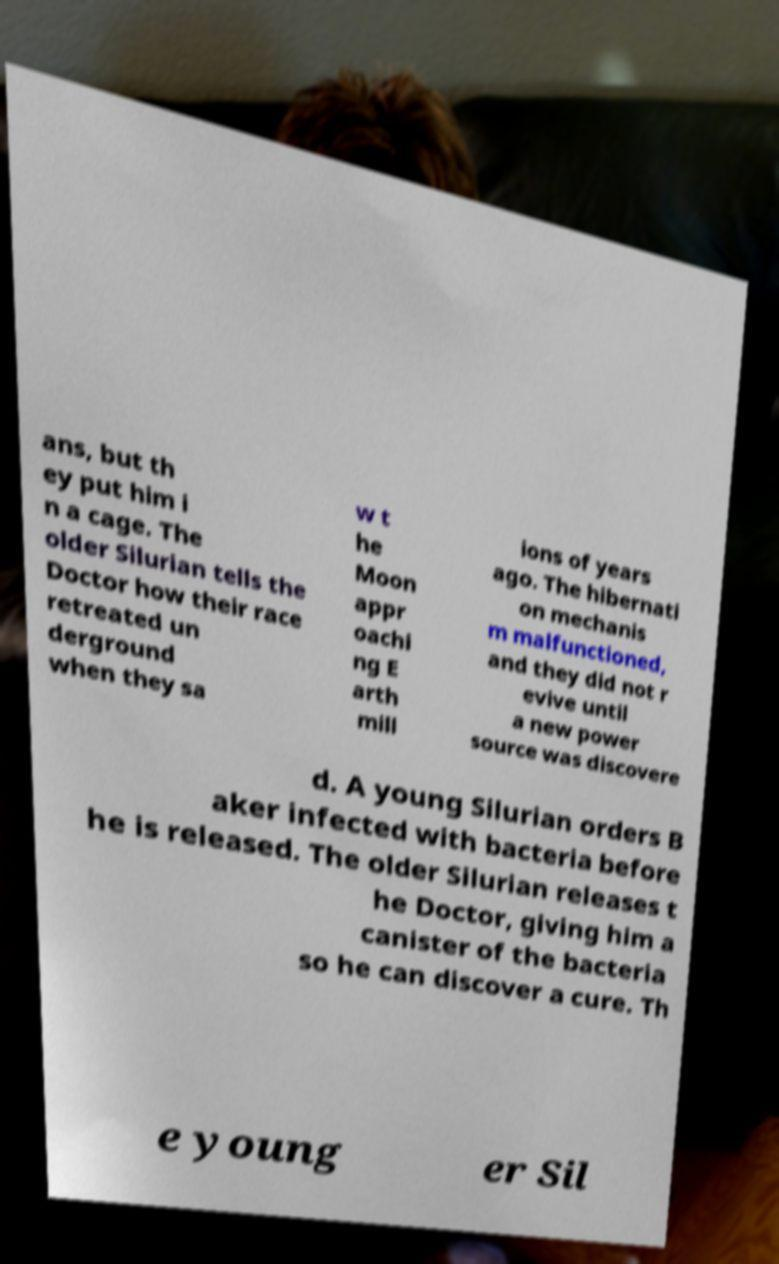What messages or text are displayed in this image? I need them in a readable, typed format. ans, but th ey put him i n a cage. The older Silurian tells the Doctor how their race retreated un derground when they sa w t he Moon appr oachi ng E arth mill ions of years ago. The hibernati on mechanis m malfunctioned, and they did not r evive until a new power source was discovere d. A young Silurian orders B aker infected with bacteria before he is released. The older Silurian releases t he Doctor, giving him a canister of the bacteria so he can discover a cure. Th e young er Sil 